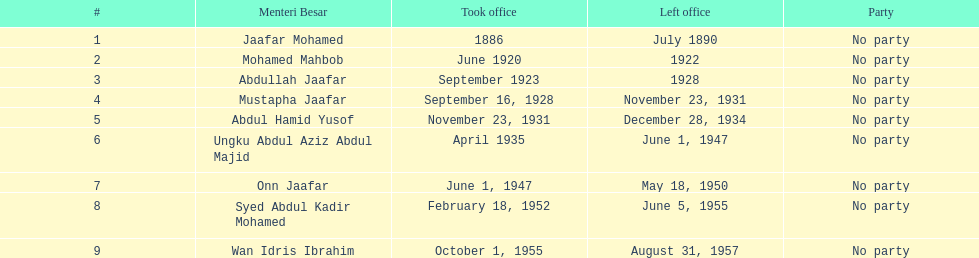Who is named below onn jaafar? Syed Abdul Kadir Mohamed. 